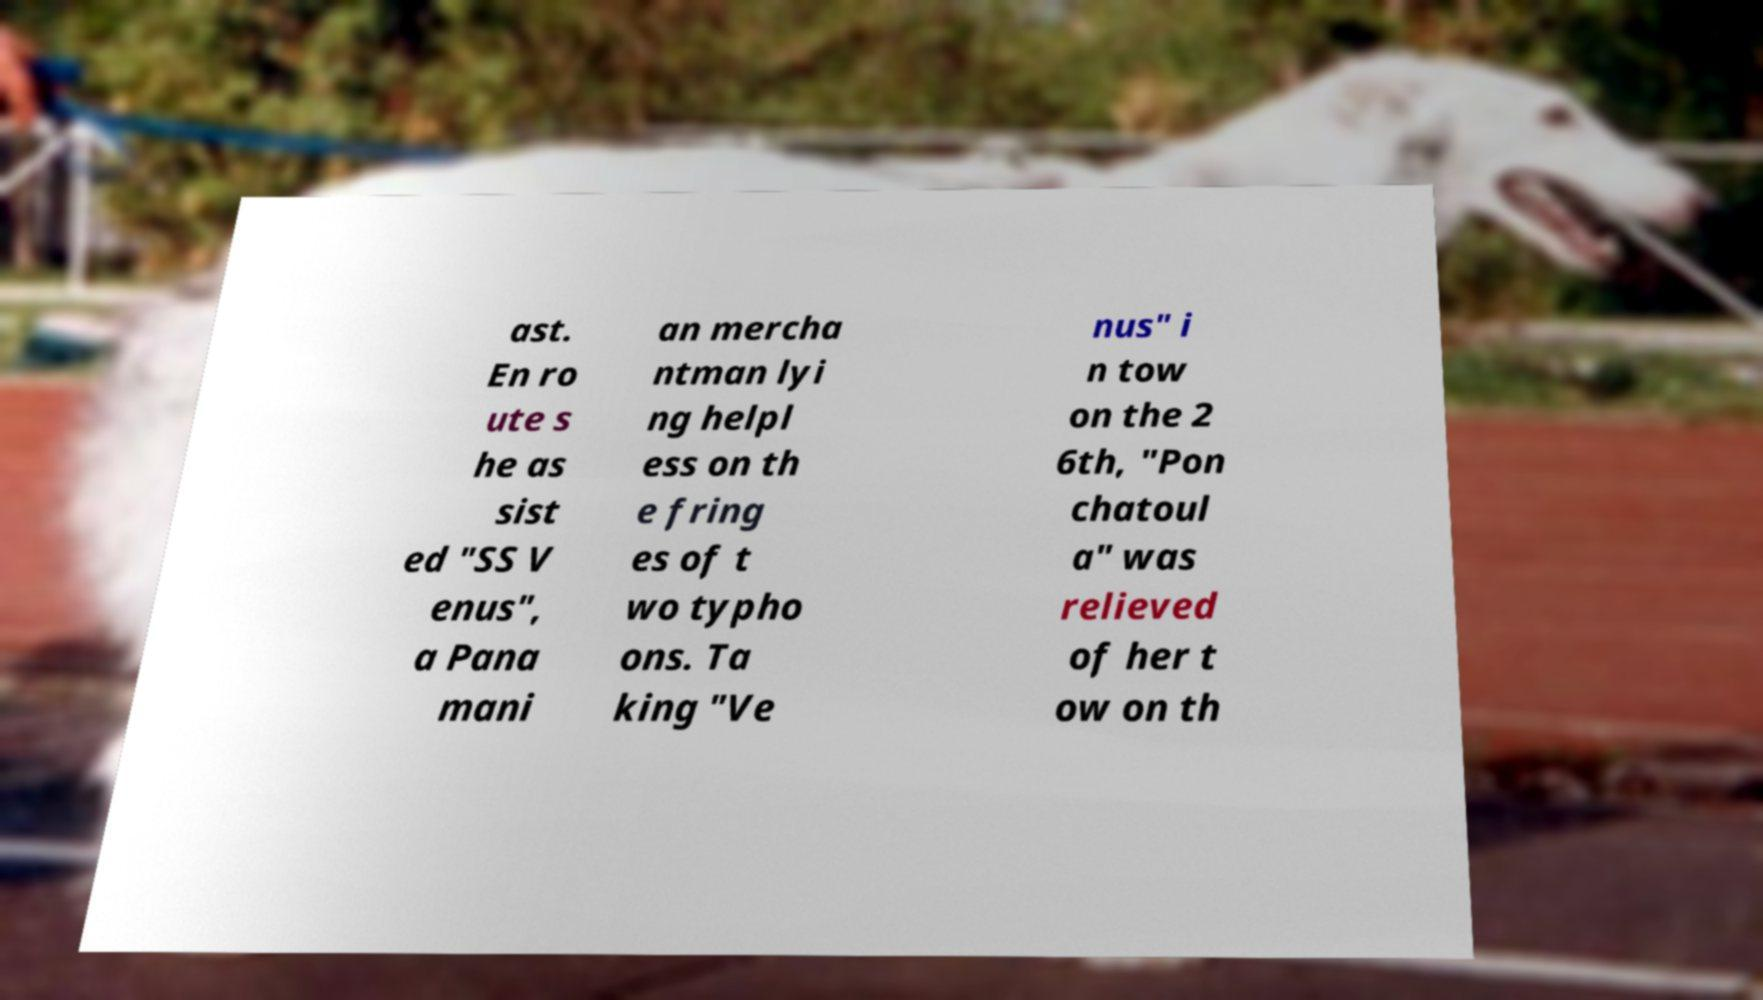For documentation purposes, I need the text within this image transcribed. Could you provide that? ast. En ro ute s he as sist ed "SS V enus", a Pana mani an mercha ntman lyi ng helpl ess on th e fring es of t wo typho ons. Ta king "Ve nus" i n tow on the 2 6th, "Pon chatoul a" was relieved of her t ow on th 